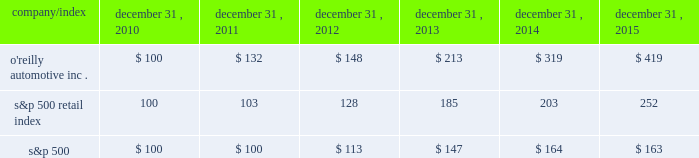Stock performance graph : the graph below shows the cumulative total shareholder return assuming the investment of $ 100 , on december 31 , 2010 , and the reinvestment of dividends thereafter , if any , in the company's common stock versus the standard and poor's s&p 500 retail index ( "s&p 500 retail index" ) and the standard and poor's s&p 500 index ( "s&p 500" ) . .

What is the roi of an investment in the s&p500 from 2010 to 2011? 
Computations: ((100 - 100) / 100)
Answer: 0.0. 